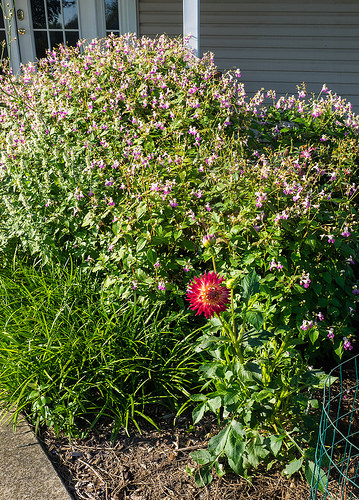<image>
Is the flower behind the building? No. The flower is not behind the building. From this viewpoint, the flower appears to be positioned elsewhere in the scene. 